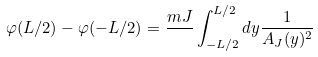Convert formula to latex. <formula><loc_0><loc_0><loc_500><loc_500>\varphi ( L / 2 ) - \varphi ( - L / 2 ) = \frac { m J } { } \int _ { - L / 2 } ^ { L / 2 } d y \frac { 1 } { A _ { J } ( y ) ^ { 2 } }</formula> 